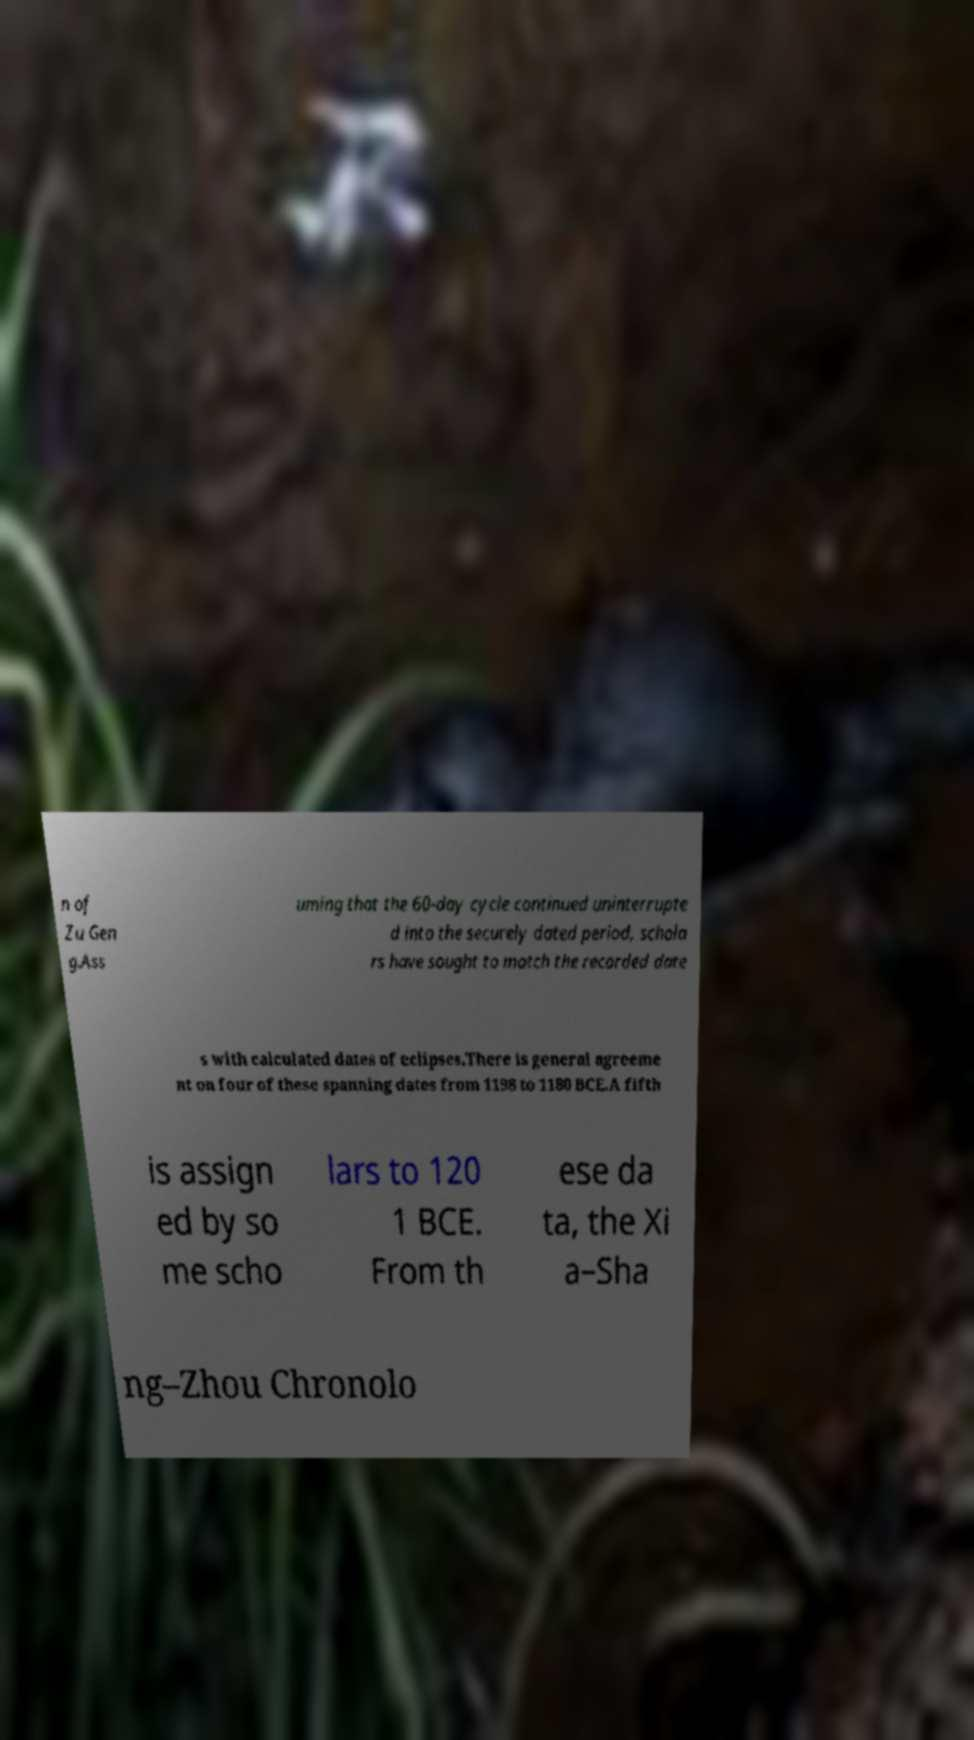Could you assist in decoding the text presented in this image and type it out clearly? n of Zu Gen g.Ass uming that the 60-day cycle continued uninterrupte d into the securely dated period, schola rs have sought to match the recorded date s with calculated dates of eclipses.There is general agreeme nt on four of these spanning dates from 1198 to 1180 BCE.A fifth is assign ed by so me scho lars to 120 1 BCE. From th ese da ta, the Xi a–Sha ng–Zhou Chronolo 